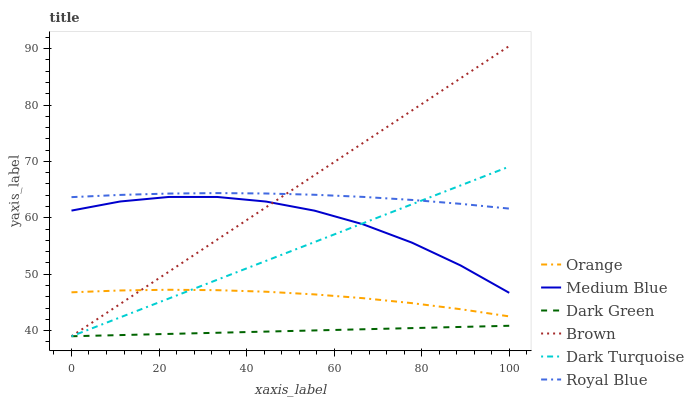Does Dark Green have the minimum area under the curve?
Answer yes or no. Yes. Does Brown have the maximum area under the curve?
Answer yes or no. Yes. Does Dark Turquoise have the minimum area under the curve?
Answer yes or no. No. Does Dark Turquoise have the maximum area under the curve?
Answer yes or no. No. Is Brown the smoothest?
Answer yes or no. Yes. Is Medium Blue the roughest?
Answer yes or no. Yes. Is Dark Turquoise the smoothest?
Answer yes or no. No. Is Dark Turquoise the roughest?
Answer yes or no. No. Does Brown have the lowest value?
Answer yes or no. Yes. Does Medium Blue have the lowest value?
Answer yes or no. No. Does Brown have the highest value?
Answer yes or no. Yes. Does Dark Turquoise have the highest value?
Answer yes or no. No. Is Dark Green less than Orange?
Answer yes or no. Yes. Is Medium Blue greater than Dark Green?
Answer yes or no. Yes. Does Dark Turquoise intersect Brown?
Answer yes or no. Yes. Is Dark Turquoise less than Brown?
Answer yes or no. No. Is Dark Turquoise greater than Brown?
Answer yes or no. No. Does Dark Green intersect Orange?
Answer yes or no. No. 